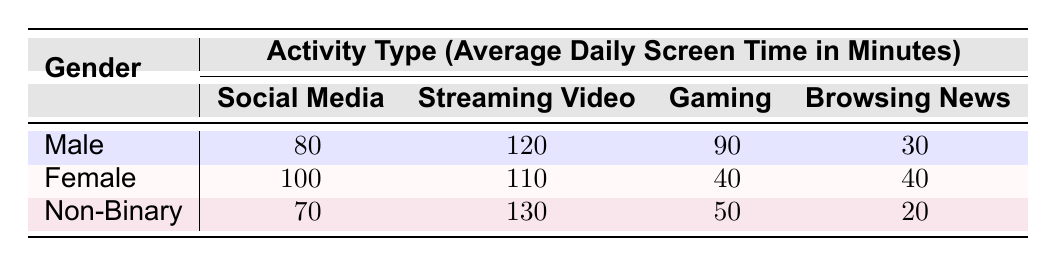What is the average daily screen time for males on social media? The table shows that the average daily screen time for males on social media is 80 minutes.
Answer: 80 Which activity type has the highest average daily screen time for females? According to the table, females spend an average of 110 minutes on streaming video, which is the highest among the listed activity types for females.
Answer: 110 Is the average daily screen time for non-binary individuals higher for streaming video or gaming? Non-binary individuals spend 130 minutes on streaming video and 50 minutes on gaming. Since 130 is higher than 50, streaming video has more screen time.
Answer: Yes, streaming video What is the total average daily screen time for males across all activity types? To find this total, add the average times: 80 (Social Media) + 120 (Streaming Video) + 90 (Gaming) + 30 (Browsing News) = 320 minutes for males.
Answer: 320 How does the average daily screen time for females on browsing news compare to males? The average daily screen time for females on browsing news is 40 minutes, while males spend 30 minutes on the same activity. 40 is higher than 30, indicating that females spend more time.
Answer: Yes, females spend more time What is the difference in average daily screen time between non-binary individuals and males for streaming video? Non-binary individuals spend 130 minutes and males spend 120 minutes on streaming video. The difference is 130 - 120 = 10 minutes, meaning non-binary individuals spend 10 more minutes than males.
Answer: 10 Which gender has the least average daily screen time for gaming? In the table, males have an average of 90 minutes, females have 40 minutes, and non-binary individuals have 50 minutes for gaming. The lowest is the average for females at 40 minutes.
Answer: Female What is the average daily screen time for males and females combined on social media? Males spend 80 minutes and females spend 100 minutes on social media. The average is (80 + 100) / 2 = 90 minutes.
Answer: 90 How many minutes do non-binary individuals spend on browsing news compared to females? Non-binary individuals spend 20 minutes and females spend 40 minutes on browsing news. This indicates non-binary individuals spend significantly less time.
Answer: Less time 